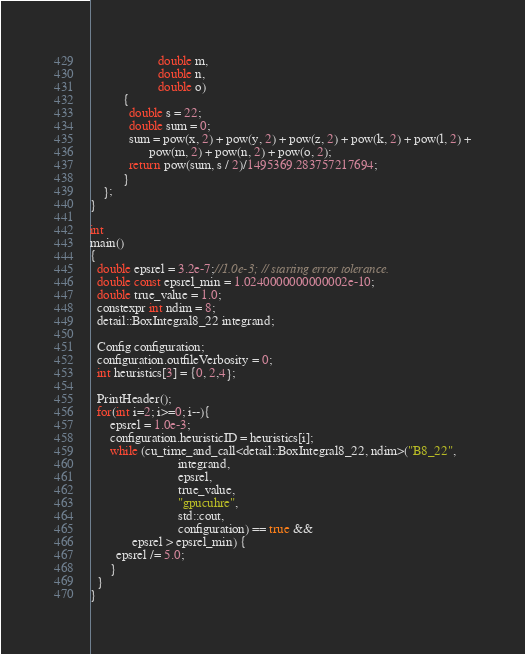<code> <loc_0><loc_0><loc_500><loc_500><_Cuda_>                     double m,
                     double n,
                     double o)
          {
            double s = 22;
            double sum = 0;
            sum = pow(x, 2) + pow(y, 2) + pow(z, 2) + pow(k, 2) + pow(l, 2) +
                  pow(m, 2) + pow(n, 2) + pow(o, 2);
            return pow(sum, s / 2)/1495369.283757217694;
          }
    };
}

int
main()
{
  double epsrel = 3.2e-7;//1.0e-3; // starting error tolerance.
  double const epsrel_min = 1.0240000000000002e-10;
  double true_value = 1.0;
  constexpr int ndim = 8;
  detail::BoxIntegral8_22 integrand;
    
  Config configuration;
  configuration.outfileVerbosity = 0;
  int heuristics[3] = {0, 2,4};
  
  PrintHeader();
  for(int i=2; i>=0; i--){
      epsrel = 1.0e-3;
      configuration.heuristicID = heuristics[i];
      while (cu_time_and_call<detail::BoxIntegral8_22, ndim>("B8_22",
                           integrand,
                           epsrel,
                           true_value,
                           "gpucuhre",
                           std::cout,
                           configuration) == true &&
             epsrel > epsrel_min) {
        epsrel /= 5.0;
      }
  }
}
</code> 